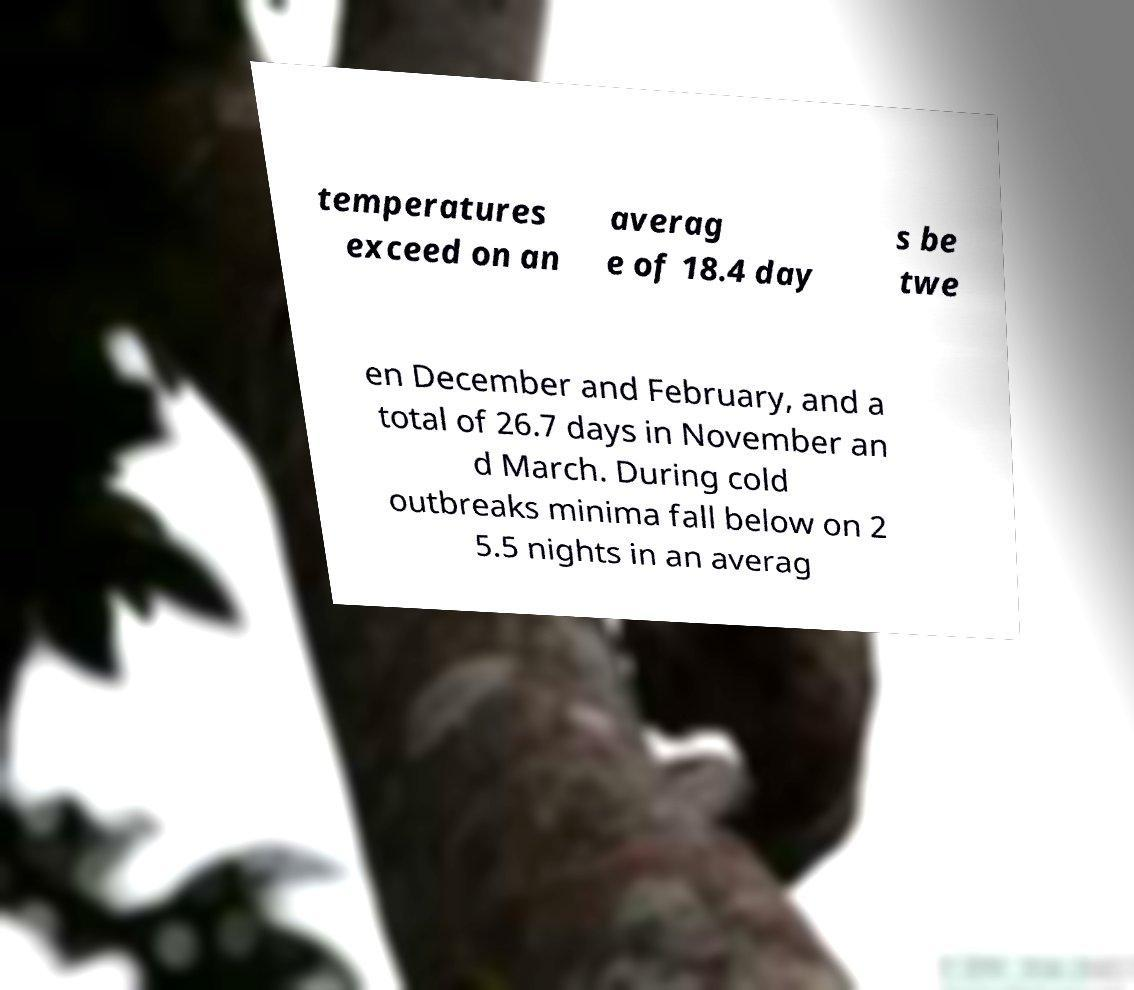Please identify and transcribe the text found in this image. temperatures exceed on an averag e of 18.4 day s be twe en December and February, and a total of 26.7 days in November an d March. During cold outbreaks minima fall below on 2 5.5 nights in an averag 